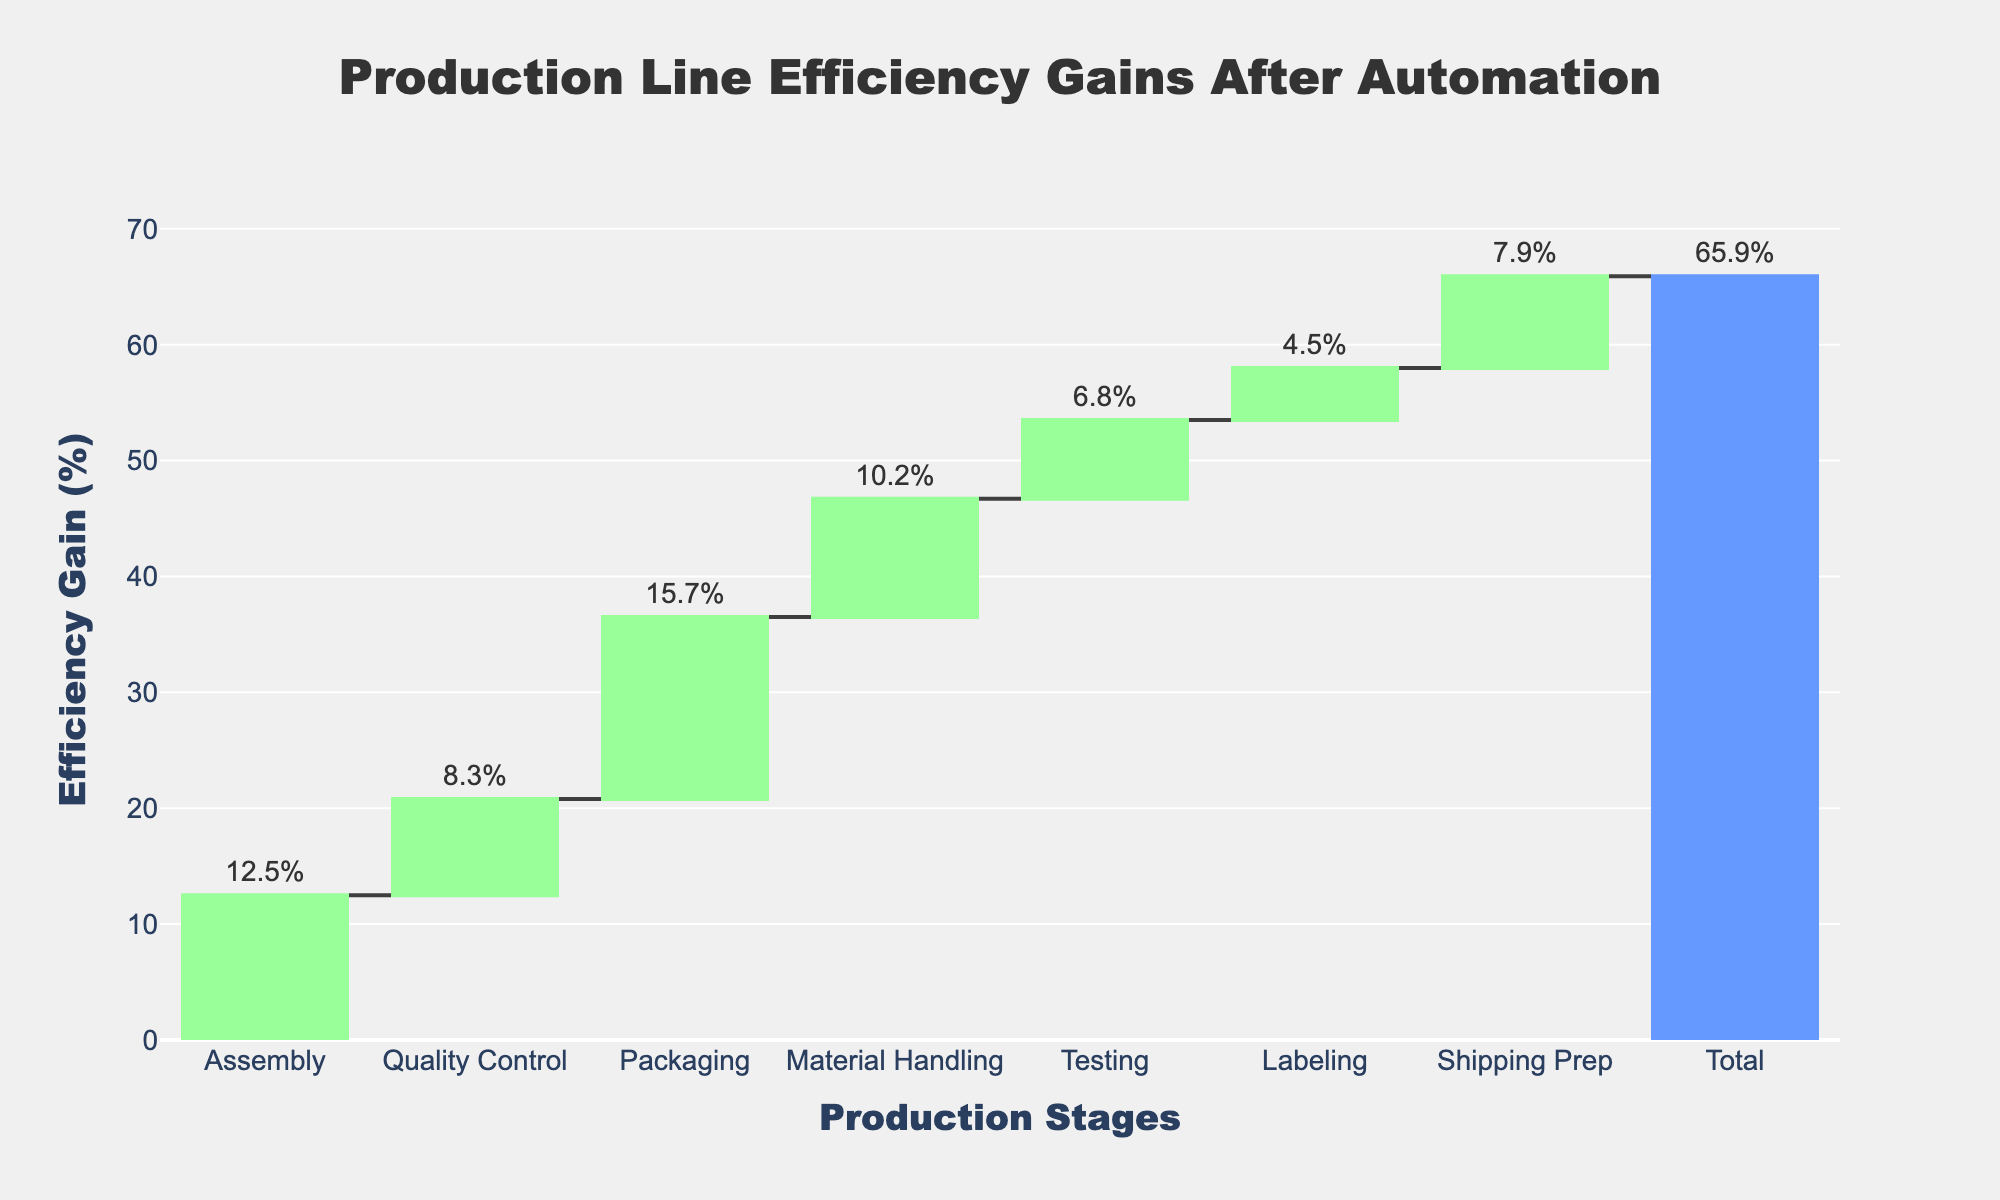What is the title of the chart? The title is located at the top center of the chart in a large font, which summarizes the main information presented. It reads "Production Line Efficiency Gains After Automation".
Answer: Production Line Efficiency Gains After Automation What is the total efficiency gain after automation? The total efficiency gain is represented by the last bar in the chart, which has a distinctive color and label indicating the cumulative value.
Answer: 65.9% Which stage has the highest efficiency gain? To determine which stage has the highest efficiency gain, compare the heights of the bars representing each stage. The tallest bar indicates the highest gain.
Answer: Packaging How much efficiency gain is achieved in the Assembly stage compared to the Material Handling stage? The Assembly stage shows an efficiency gain of 12.5%, while the Material Handling stage has a gain of 10.2%. The difference can be found by subtracting the smaller value from the larger one.
Answer: 2.3% Which stages have more than 10% efficiency gain? Check the bars labeled with efficiency gains higher than 10%. These stages are Assembly, Packaging, and Material Handling.
Answer: Assembly, Packaging, Material Handling What is the combined efficiency gain of Quality Control, Testing, and Labeling stages? Add the efficiency gains of the Quality Control (8.3%), Testing (6.8%), and Labeling (4.5%) stages. Sum these values to get the combined gain. 8.3 + 6.8 + 4.5 = 19.6%
Answer: 19.6% Does the Quality Control stage have a higher or lower efficiency gain than the Shipping Prep stage? Compare the heights of the bars representing the Quality Control and Shipping Prep stages. Quality Control shows an efficiency gain of 8.3%, while Shipping Prep shows a gain of 7.9%.
Answer: Higher Which stage has the smallest efficiency gain and what is its value? The smallest efficiency gain is indicated by the shortest bar in the chart. The Labeling stage shows the smallest efficiency gain.
Answer: Labeling, 4.5% Are any of the efficiency gains color-coded differently, and if so, what might this indicate? The bars in the chart use different colors to indicate specific types of data: relative increases and the total gain. The final total gain bar is color-coded separately.
Answer: Yes, bars are color-coded differently What is the average efficiency gain per stage (excluding the total)? Sum all the individual efficiency gains and then divide by the number of stages, excluding the total. The sum is 65.9%, and there are 8 stages. Thus, 65.9 / 8 = 8.2375%.
Answer: 8.2% 